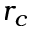<formula> <loc_0><loc_0><loc_500><loc_500>r _ { c }</formula> 